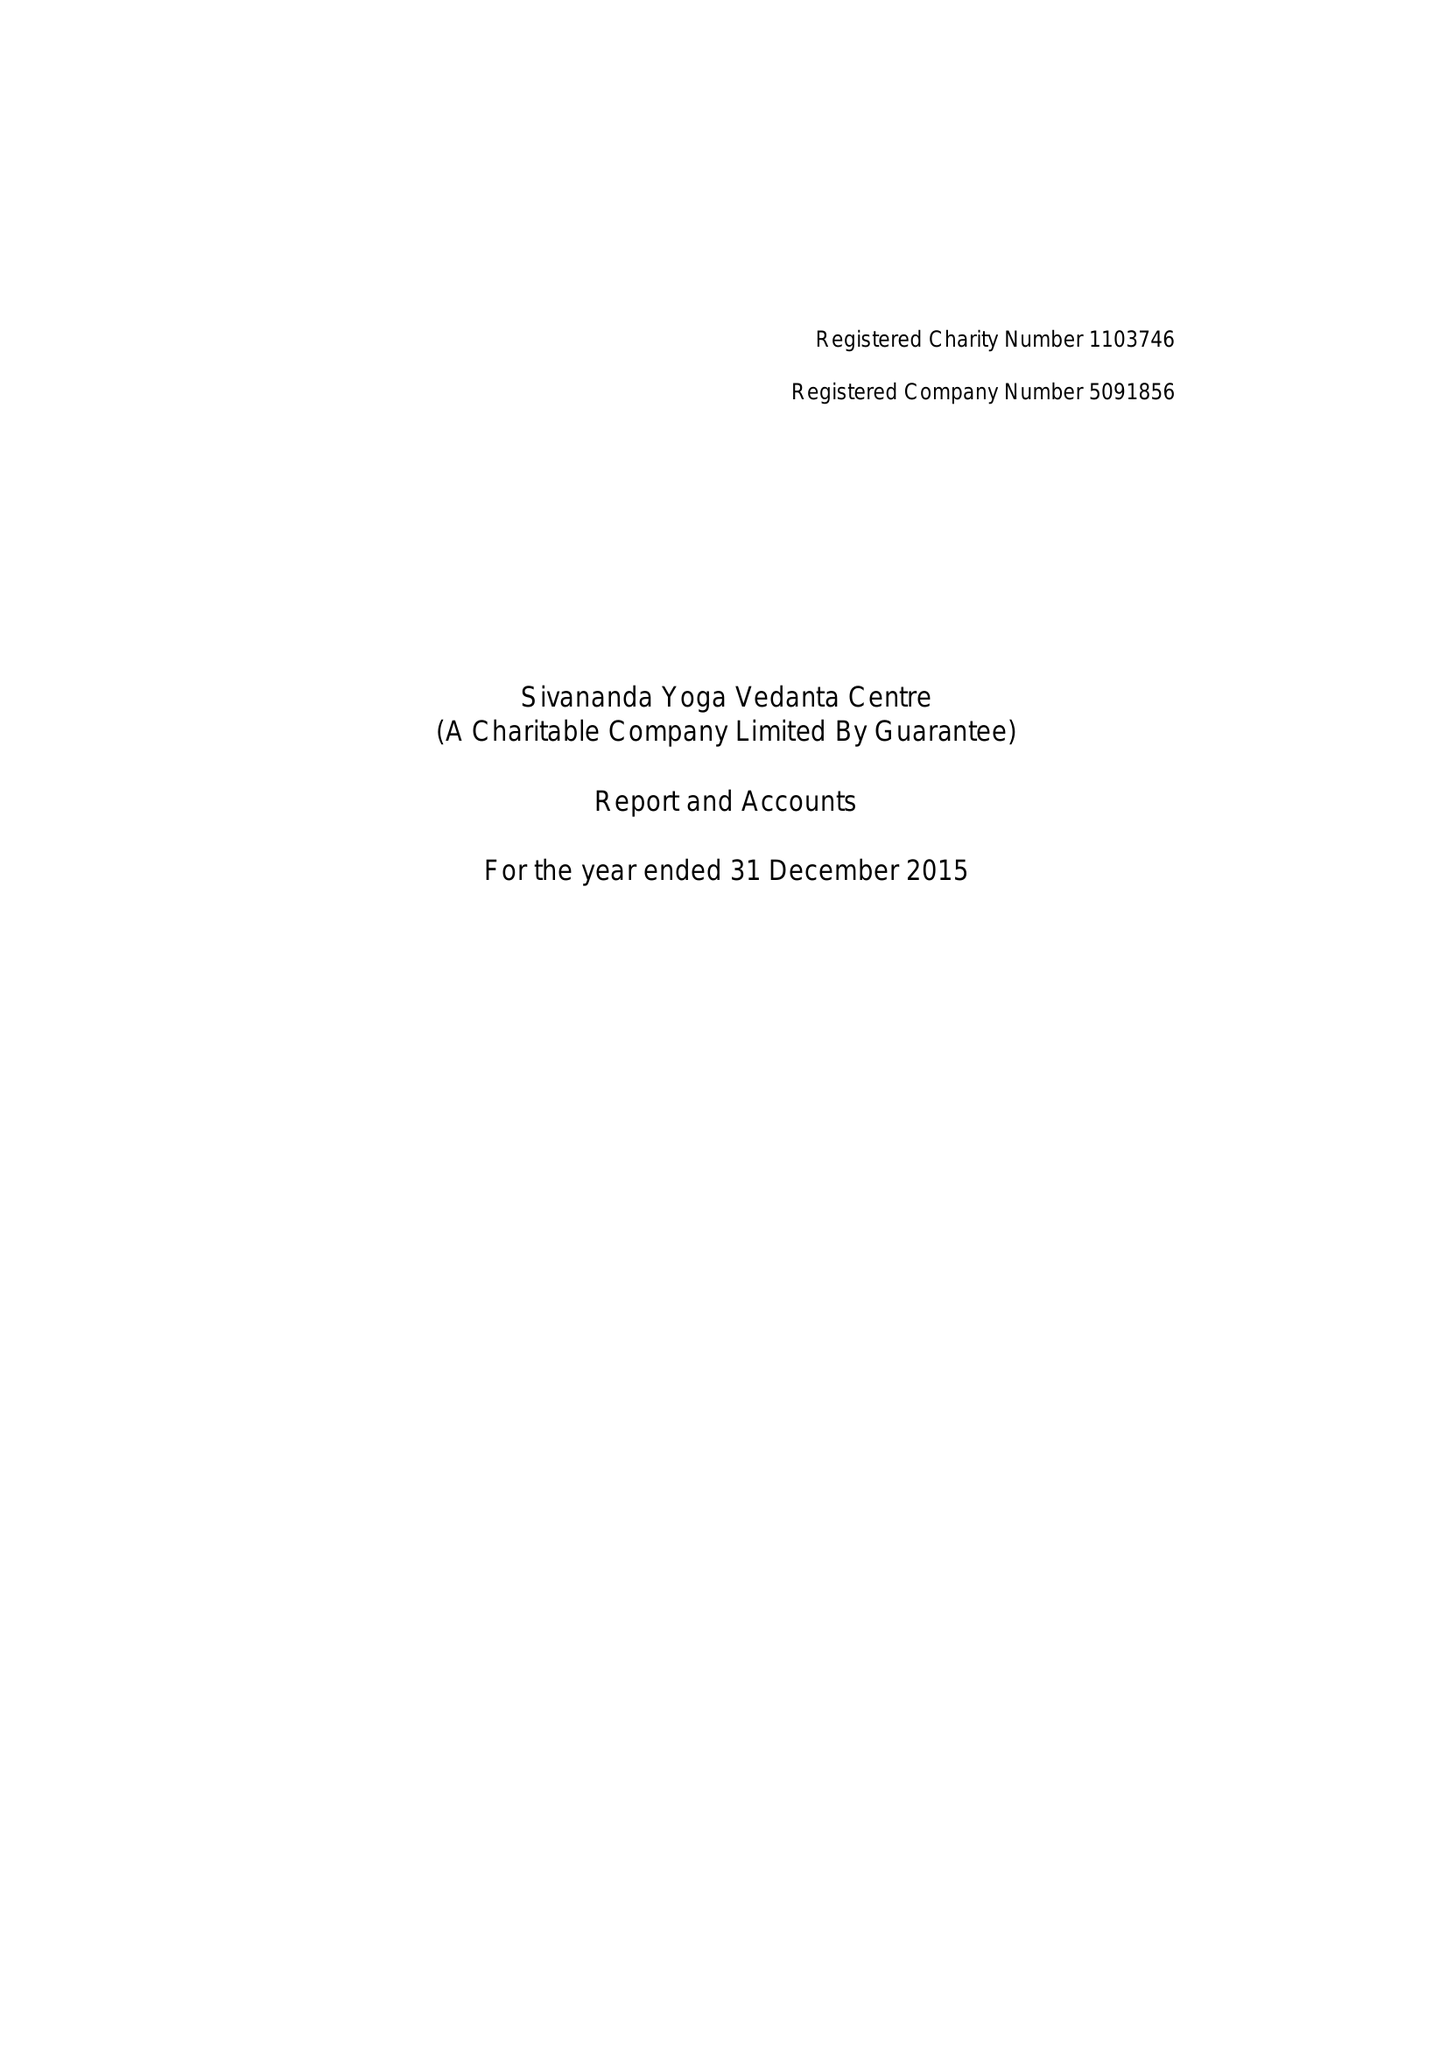What is the value for the spending_annually_in_british_pounds?
Answer the question using a single word or phrase. 300908.00 